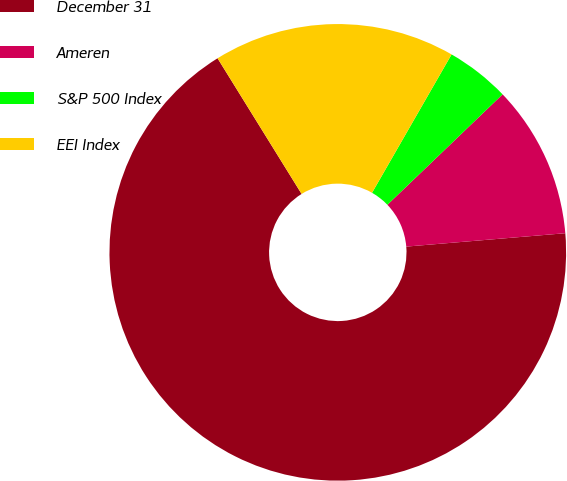Convert chart to OTSL. <chart><loc_0><loc_0><loc_500><loc_500><pie_chart><fcel>December 31<fcel>Ameren<fcel>S&P 500 Index<fcel>EEI Index<nl><fcel>67.51%<fcel>10.83%<fcel>4.53%<fcel>17.13%<nl></chart> 